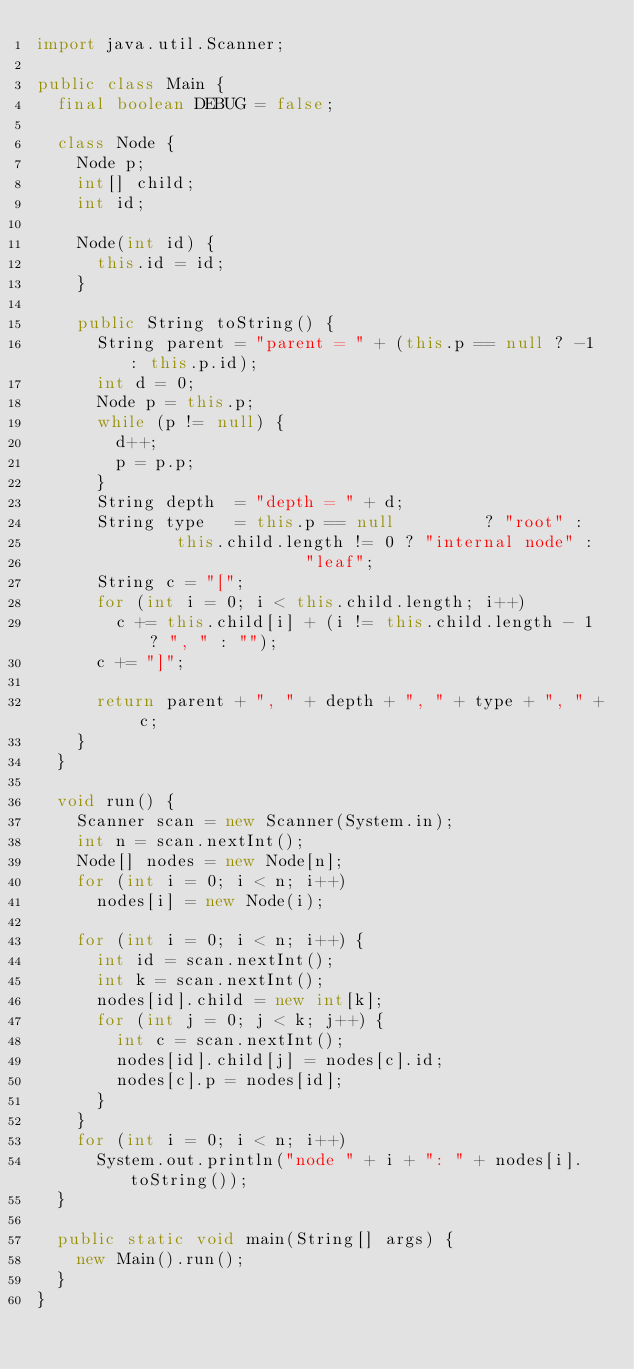<code> <loc_0><loc_0><loc_500><loc_500><_Java_>import java.util.Scanner;

public class Main {
	final boolean DEBUG = false;

	class Node {
		Node p;
		int[] child;
		int id;
		
		Node(int id) {
			this.id = id;
		}

		public String toString() {
			String parent = "parent = " + (this.p == null ? -1 : this.p.id);
			int d = 0;
			Node p = this.p;
			while (p != null) {
				d++;
				p = p.p;
			}
			String depth  = "depth = " + d;
			String type   = this.p == null         ? "root" :
							this.child.length != 0 ? "internal node" :
													 "leaf";
			String c = "[";
			for (int i = 0; i < this.child.length; i++)
				c += this.child[i] + (i != this.child.length - 1 ? ", " : "");
			c += "]";

			return parent + ", " + depth + ", " + type + ", " + c;
		}
	}
	
	void run() {
		Scanner scan = new Scanner(System.in);
		int n = scan.nextInt();
		Node[] nodes = new Node[n];
		for (int i = 0; i < n; i++)
			nodes[i] = new Node(i);

		for (int i = 0; i < n; i++) {
			int id = scan.nextInt();
			int k = scan.nextInt();
			nodes[id].child = new int[k];
			for (int j = 0; j < k; j++) {
				int c = scan.nextInt();
				nodes[id].child[j] = nodes[c].id;
				nodes[c].p = nodes[id];
			}
		}
		for (int i = 0; i < n; i++)
			System.out.println("node " + i + ": " + nodes[i].toString());
	}

	public static void main(String[] args) {
		new Main().run();
	}
}

</code> 